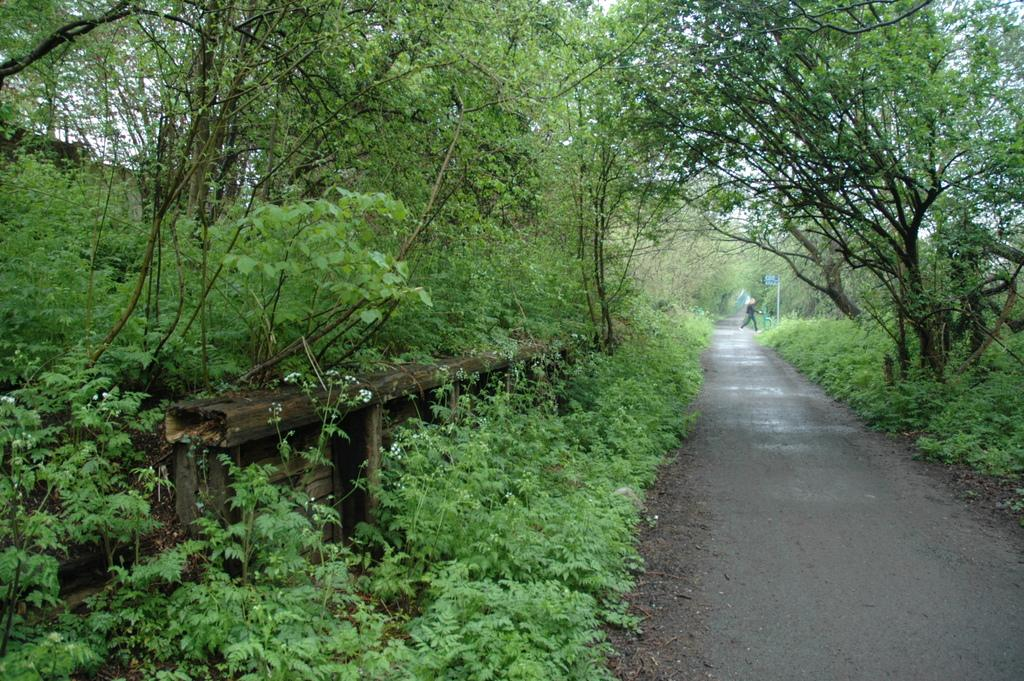What type of vegetation can be seen in the image? There are trees and plants in the image. What is the person in the image doing? There is a person walking in the image. Where is the kitten reading a book in the image? There is no kitten or book present in the image. 